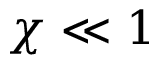<formula> <loc_0><loc_0><loc_500><loc_500>\chi \ll 1</formula> 